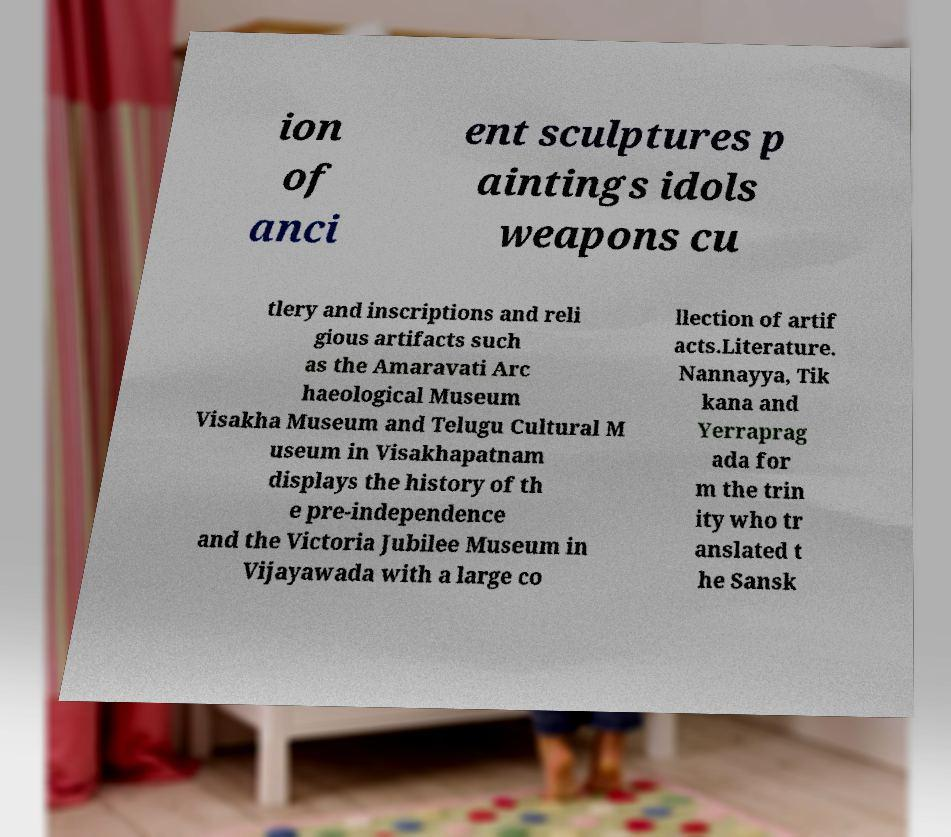Can you accurately transcribe the text from the provided image for me? ion of anci ent sculptures p aintings idols weapons cu tlery and inscriptions and reli gious artifacts such as the Amaravati Arc haeological Museum Visakha Museum and Telugu Cultural M useum in Visakhapatnam displays the history of th e pre-independence and the Victoria Jubilee Museum in Vijayawada with a large co llection of artif acts.Literature. Nannayya, Tik kana and Yerraprag ada for m the trin ity who tr anslated t he Sansk 